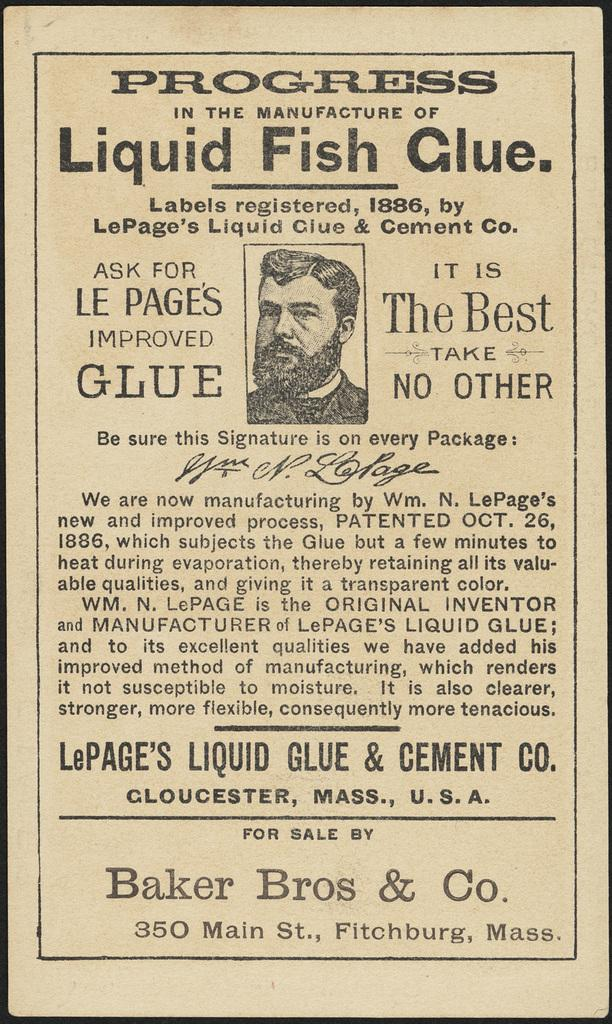What is present in the image? There is a poster in the image. What can be seen on the poster? The poster has a person's image on it. Is there anything else related to the poster in the image? Yes, there is a note around the poster. How many cherries are on the windowsill in the image? There are no cherries or windowsill present in the image; it only features a poster with a person's image and a note around it. 